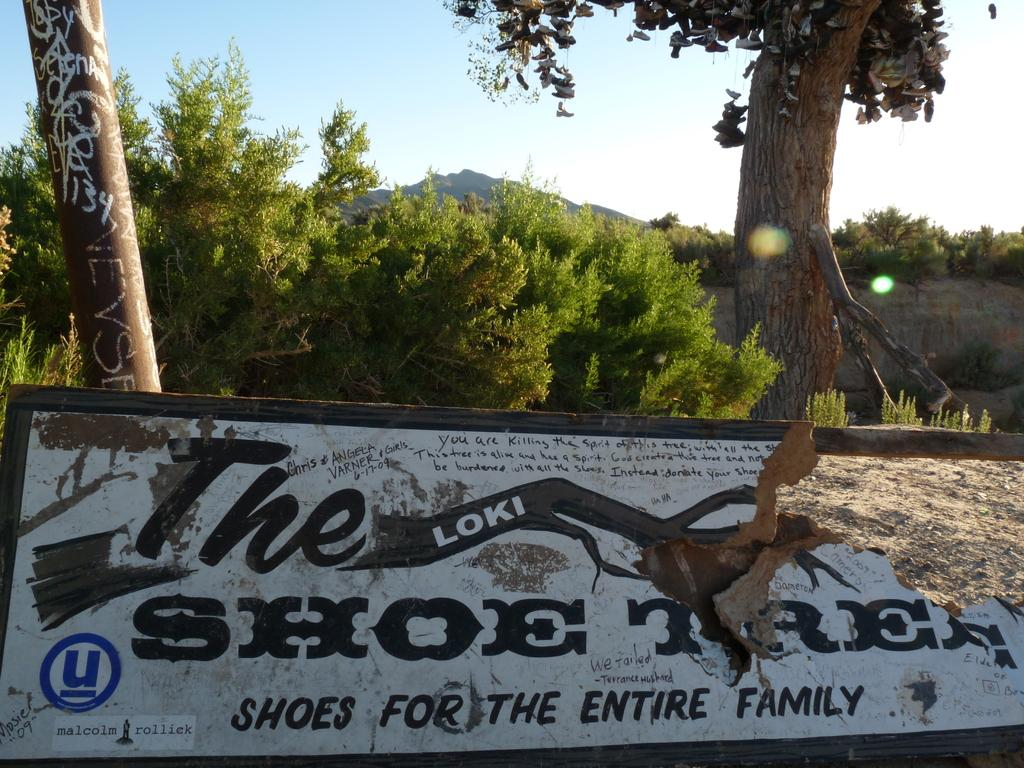What is the main object in the image? There is a board in the image. What can be seen in the background of the image? There is a pole, plants, trees, and mountains visible in the background of the image. What is the condition of the sky in the image? The sky is visible in the image, and there are clouds present. How many people are jumping on the board in the image? There are no people visible in the image, and therefore no one is jumping on the board. What is the temperature like in the image? The provided facts do not mention the temperature or heat, so it cannot be determined from the image. 